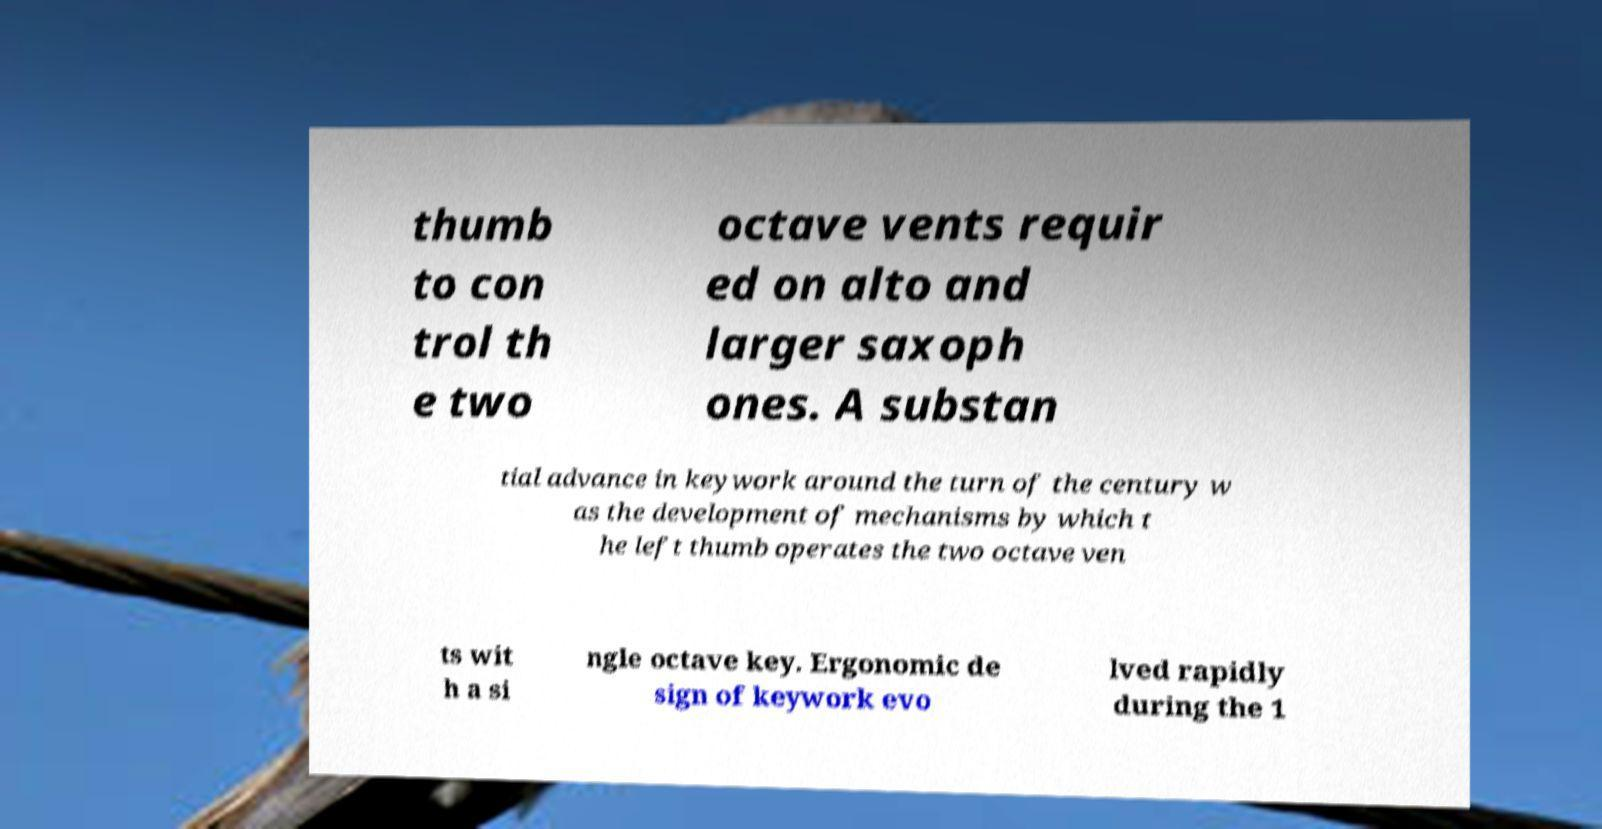Can you accurately transcribe the text from the provided image for me? thumb to con trol th e two octave vents requir ed on alto and larger saxoph ones. A substan tial advance in keywork around the turn of the century w as the development of mechanisms by which t he left thumb operates the two octave ven ts wit h a si ngle octave key. Ergonomic de sign of keywork evo lved rapidly during the 1 